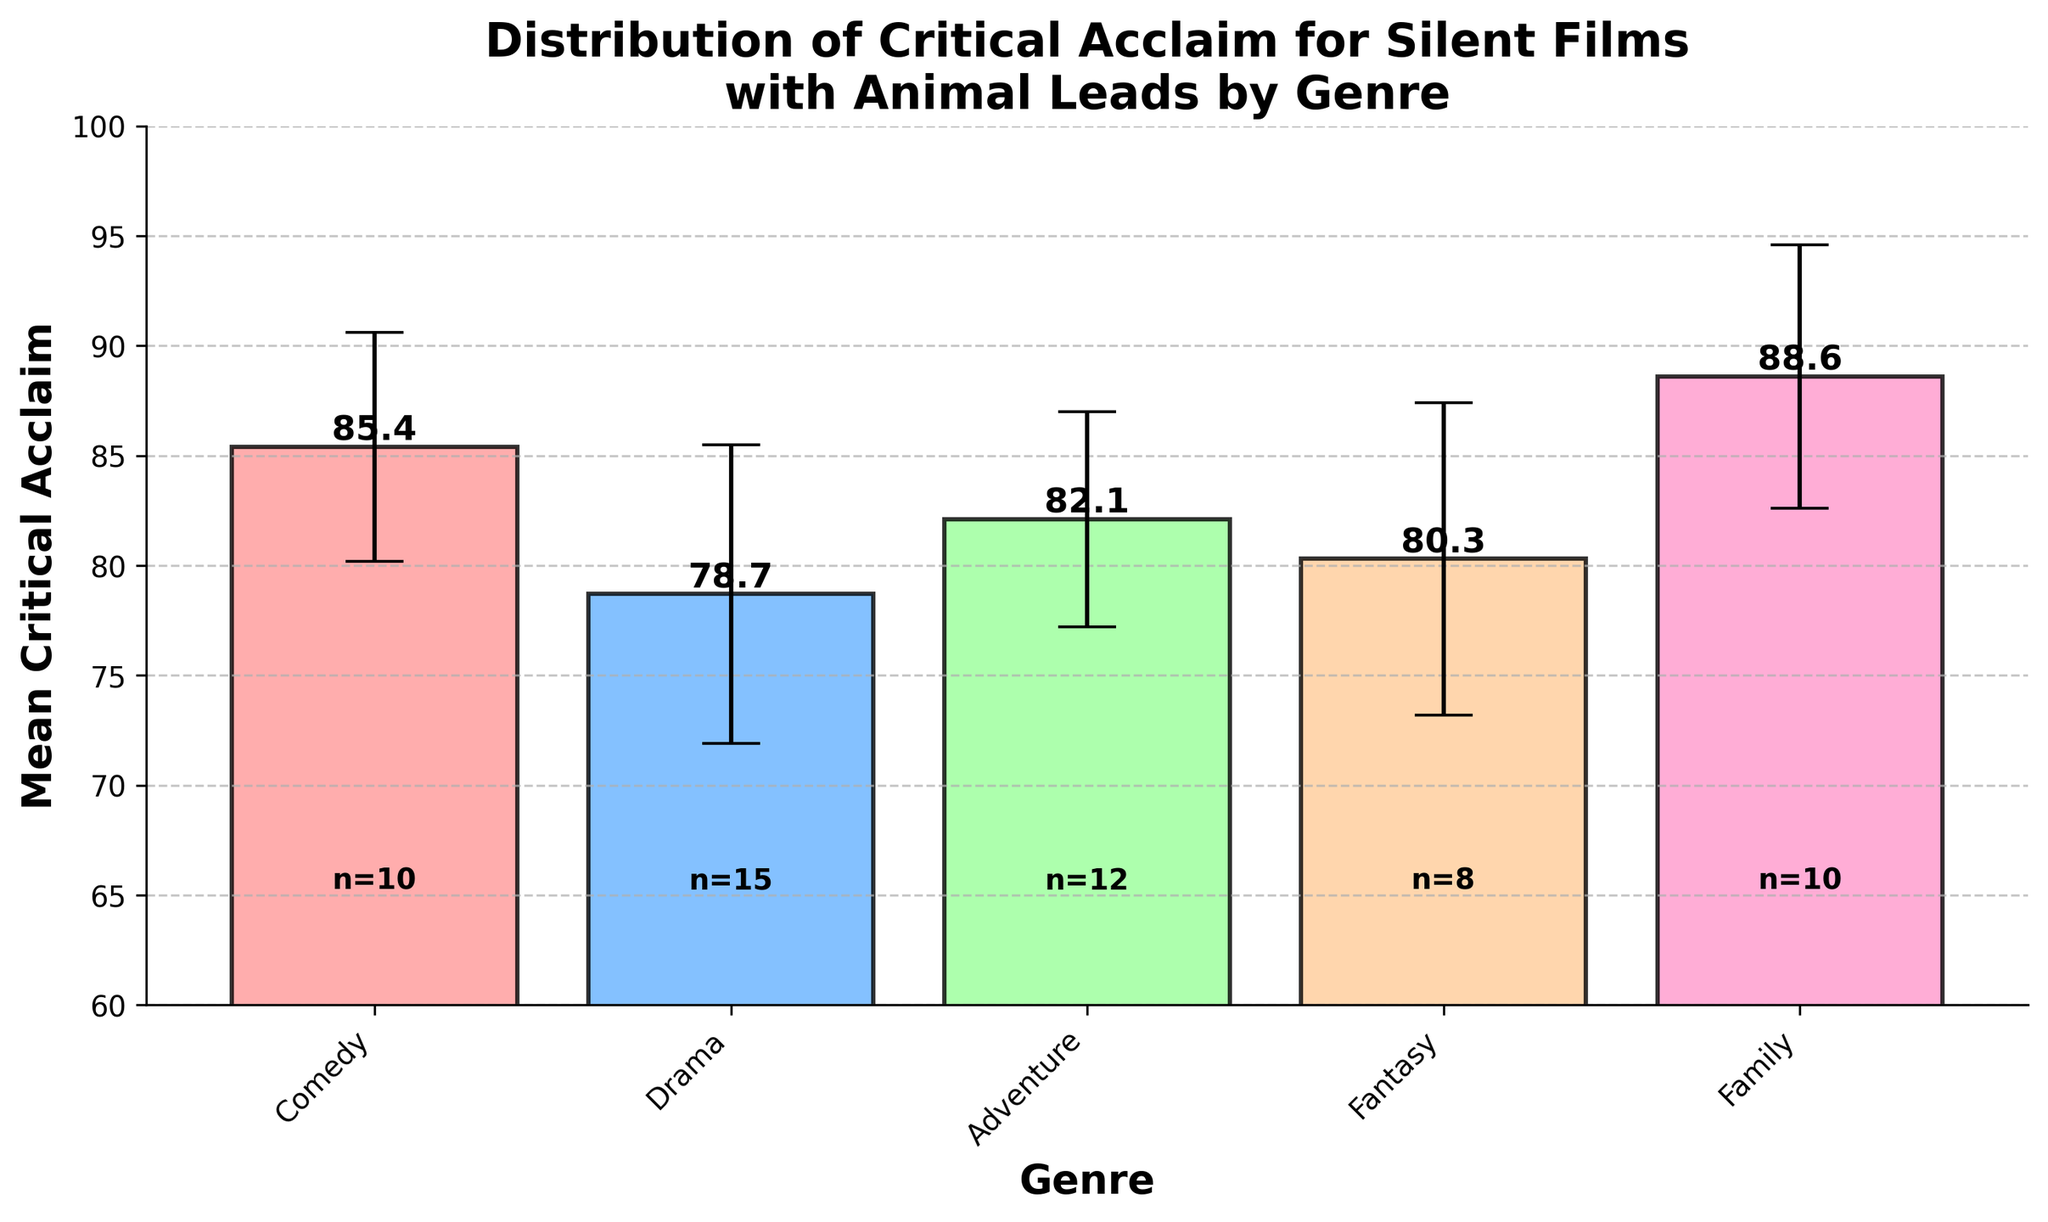What is the genre with the highest mean critical acclaim? The genre with the highest bar represents the highest mean critical acclaim. This is marked by the bar labeled "Family" with a height of 88.6.
Answer: Family Which genre has the largest error margin? The error margin is visually represented by the length of the error bars. The "Fantasy" genre has the longest error bars, corresponding to a standard deviation of 7.1.
Answer: Fantasy Which genre features the smallest number of reviews? The number of reviews is noted below each bar. The "Fantasy" genre has "n=8" noted below it, which is the smallest number of reviews.
Answer: Fantasy How much higher is the mean critical acclaim of "Family" films compared to "Drama" films? Subtract the mean critical acclaim of "Drama" (78.7) from that of "Family" (88.6). 88.6 - 78.7 equals 9.9.
Answer: 9.9 Which genre has the lowest mean critical acclaim, and what is its value? The genre with the shortest bar represents the lowest mean critical acclaim. This is the "Drama" genre with a mean critical acclaim of 78.7.
Answer: Drama, 78.7 What is the average mean critical acclaim across all genres? Calculate the average of the mean critical acclaim values: (85.4 + 78.7 + 82.1 + 80.3 + 88.6) / 5 = 83.02.
Answer: 83.0 Which two genres have the closest mean critical acclaim values? Compare the mean critical acclaim values to find the smallest difference: "Comedy" (85.4) and "Adventure" (82.1) have a difference of 3.3 which is the smallest among the pair comparisons. 85.4 - 82.1 = 3.3.
Answer: Comedy and Adventure What is the combined number of reviews for the "Comedy" and "Family" genres? Add the number of reviews for "Comedy" (10) and "Family" (10): 10 + 10 = 20.
Answer: 20 Which genre shows a higher critical acclaim: "Fantasy" or "Adventure"? Compare the heights of the bars for "Fantasy" (80.3) and "Adventure" (82.1). "Adventure" has a higher mean critical acclaim.
Answer: Adventure 